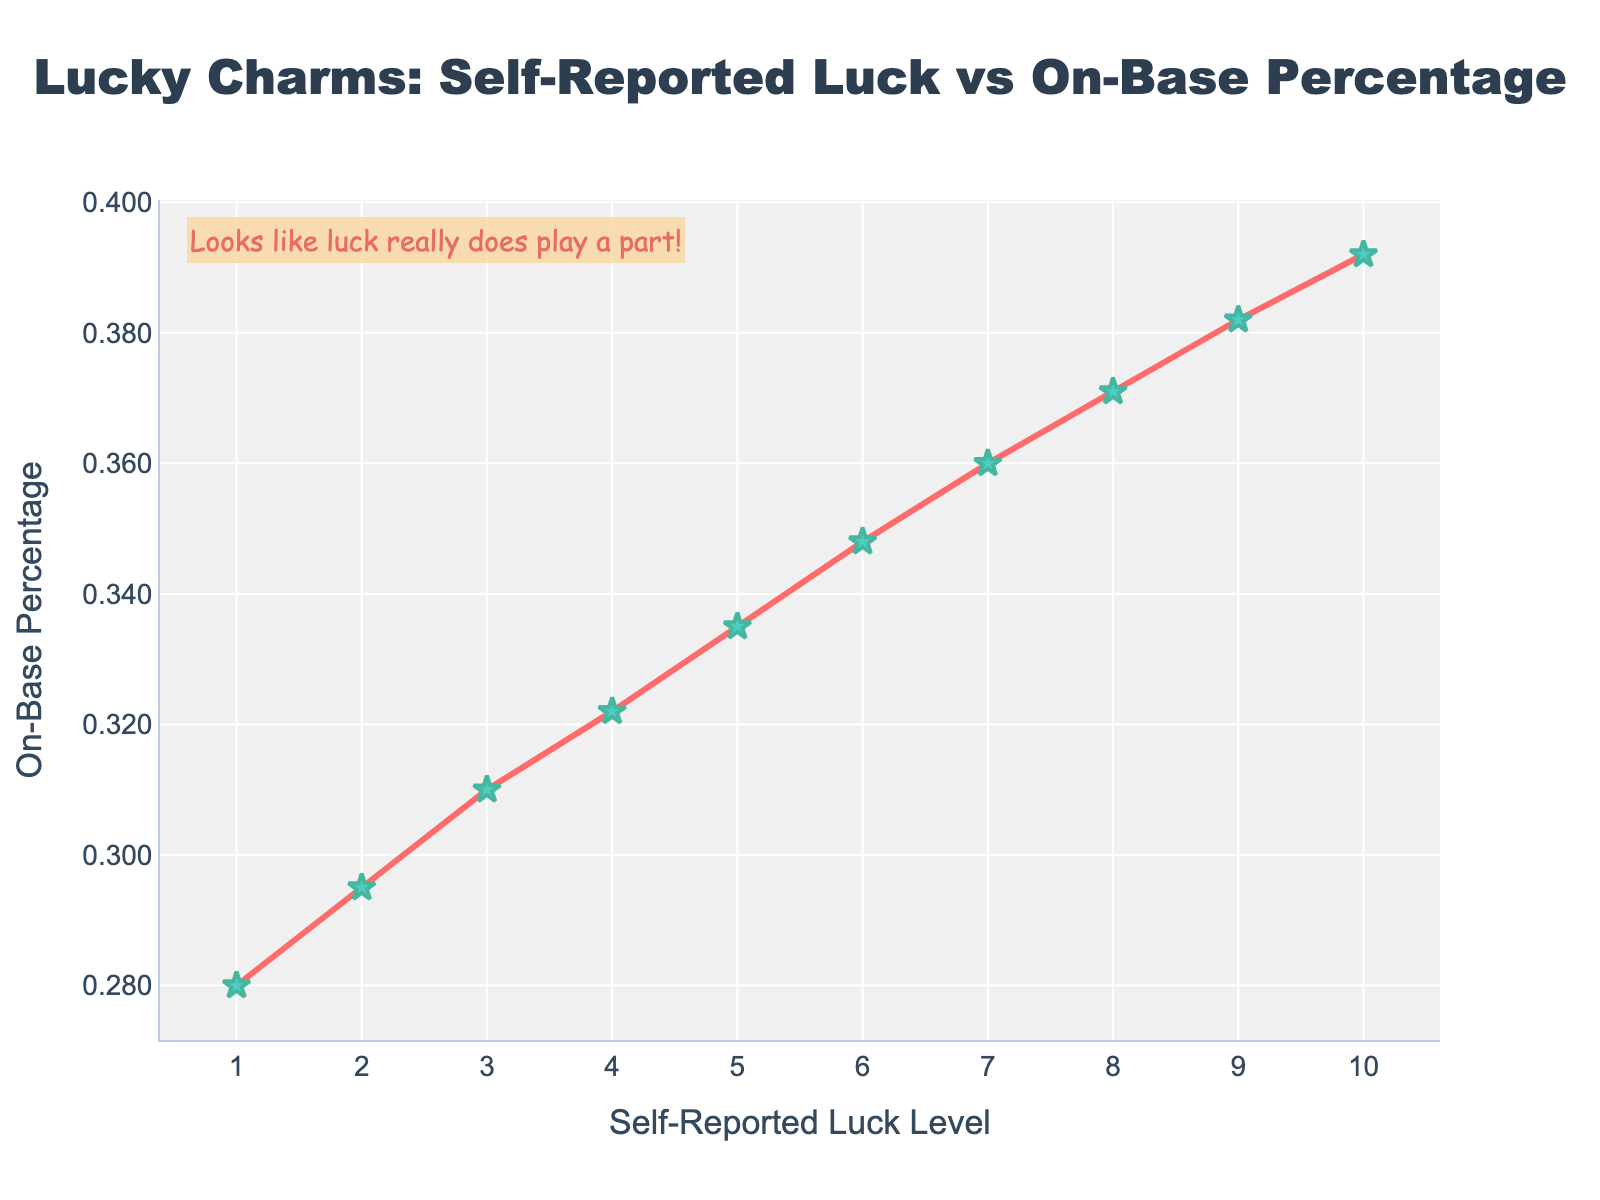What is the highest On-Base Percentage reported? To find the highest On-Base Percentage, look for the maximum y-value on the vertical axis. The highest On-Base Percentage is at the topmost point of the graph, which corresponds to a value of 0.392.
Answer: 0.392 What is the Self-Reported Luck level corresponding to an On-Base Percentage of 0.371? Locate the y-value of 0.371 on the vertical axis and trace it horizontally to the x-value. The corresponding Self-Reported Luck level is 8.
Answer: 8 Does a higher self-reported luck level generally correspond to a higher On-Base Percentage? Observe the overall trend line of the plot. As the self-reported luck level on the x-axis increases, the on-base percentage on the y-axis also increases, indicating a positive correlation.
Answer: Yes Which player reported a luck level of 5, and what was their on-base percentage? Locate the x-value of 5 on the horizontal axis and trace it vertically to find the corresponding y-value. The on-base percentage at this point is 0.335.
Answer: 0.335 What is the difference in On-Base Percentage between players with a luck level of 2 and 10? Find the on-base percentages for luck levels 2 and 10 (0.295 and 0.392 respectively) and calculate the difference: 0.392 - 0.295 = 0.097.
Answer: 0.097 What is the midpoint On-Base Percentage value between the luck levels of 4 and 7? Calculate the average of the on-base percentages at luck levels 4 and 7. The values are 0.322 and 0.360, respectively. The midpoint is: (0.322 + 0.360) / 2 = 0.341.
Answer: 0.341 Between which luck levels does the On-Base Percentage jump the most? Compare the differences in on-base percentages between successive luck levels. The largest jump is between 9 (0.382) and 10 (0.392), with a difference of 0.392 - 0.382 = 0.010.
Answer: Between 9 and 10 What visual element indicates the presence of an annotation, and what does it say? Look for text placed outside the main plot area. There is a textbox near the top left that reads, "Looks like luck really does play a part!"
Answer: Looks like luck really does play a part! How does the color coding of the markers and lines help in interpreting the data? The green star markers make the individual data points stand out clearly, while the red line connects these points smoothly to indicate the trend. This helps in visualizing the correlation between luck and on-base percentage.
Answer: Green stars and a red line 